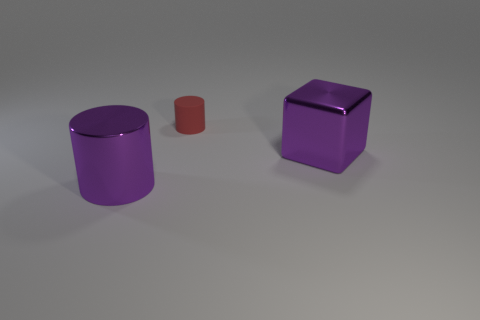Are there any tiny brown objects made of the same material as the large purple block?
Offer a very short reply. No. Are the large cube and the large cylinder made of the same material?
Offer a very short reply. Yes. How many cubes are large metal things or red things?
Give a very brief answer. 1. The large object that is made of the same material as the large block is what color?
Provide a short and direct response. Purple. Is the number of small red matte cylinders less than the number of small yellow rubber spheres?
Offer a terse response. No. There is a object that is on the left side of the small red matte cylinder; does it have the same shape as the object behind the big metallic cube?
Your answer should be compact. Yes. How many things are either yellow metallic blocks or large cubes?
Your response must be concise. 1. The object that is the same size as the purple cylinder is what color?
Ensure brevity in your answer.  Purple. There is a purple thing in front of the shiny block; how many purple objects are to the right of it?
Give a very brief answer. 1. How many things are right of the large purple cylinder and left of the metallic cube?
Your answer should be very brief. 1. 